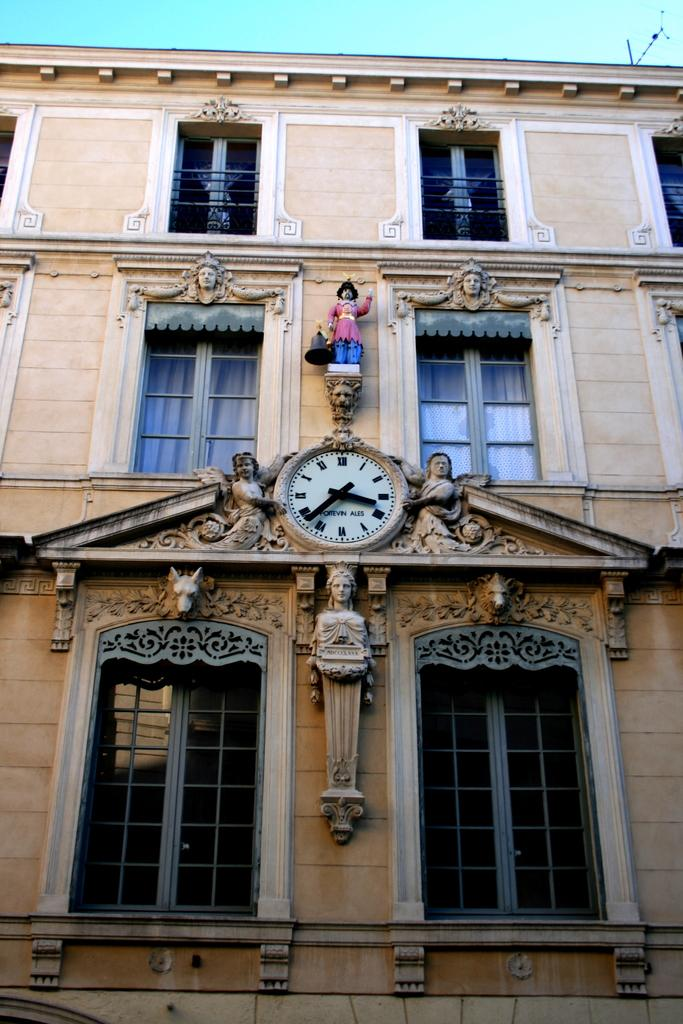<image>
Provide a brief description of the given image. an ornate building with a clock saying it is twenty to four 